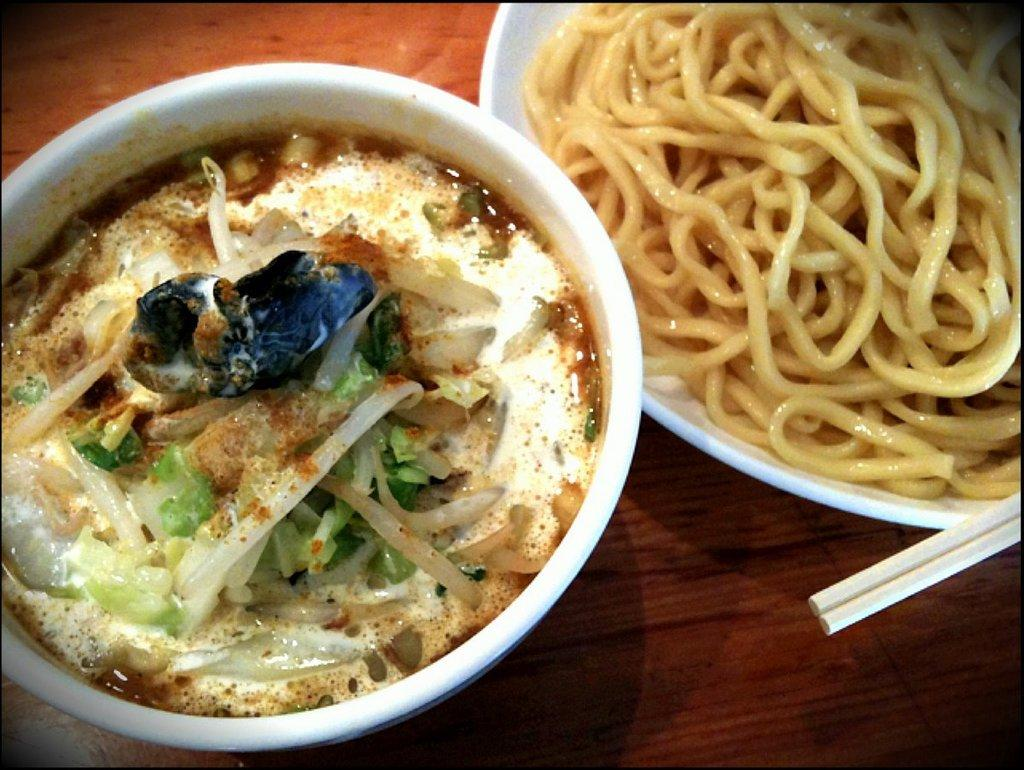What is in the bowls that are visible in the image? There are two bowls with food in the image. What utensils are present in the image? There are two chopsticks in the image. What type of surface are the food bowls placed on? The food bowls are placed on a wooden surface. What type of event is taking place in the image? There is no indication of an event taking place in the image; it simply shows two bowls with food and two chopsticks on a wooden surface. 